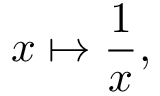Convert formula to latex. <formula><loc_0><loc_0><loc_500><loc_500>x \mapsto { \frac { 1 } { x } } ,</formula> 